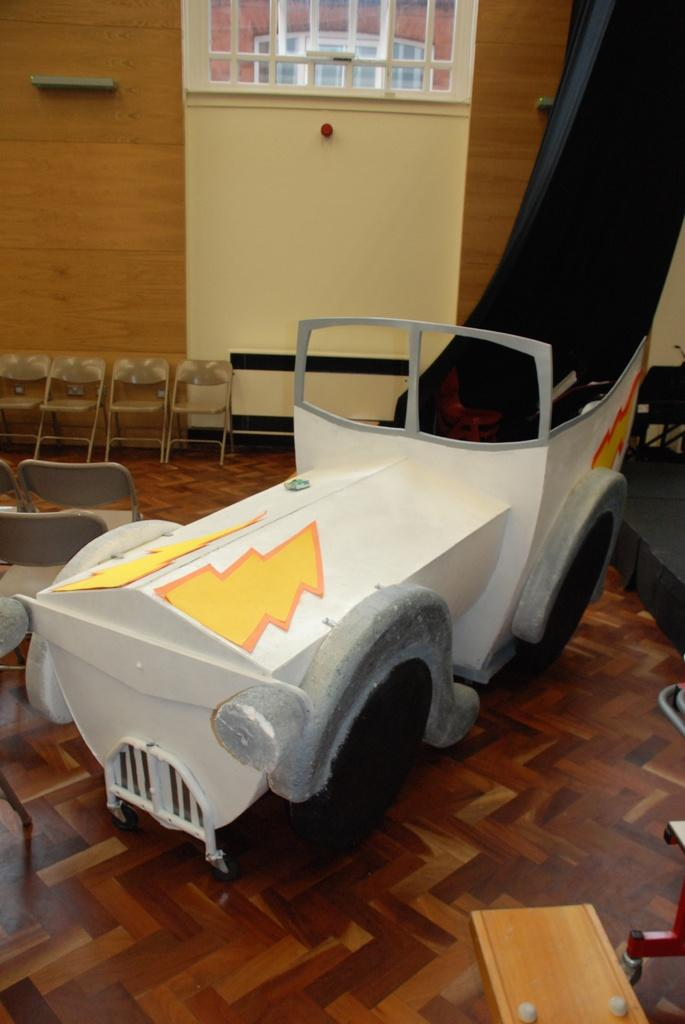What object in the image is designed for play or entertainment? There is a toy in the image. What type of furniture is present in the image? There are chairs in the image. What color is the silk on the daughter's lip in the image? There is no daughter, lip, or silk present in the image. 